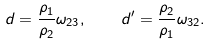<formula> <loc_0><loc_0><loc_500><loc_500>d = \frac { \rho _ { 1 } } { \rho _ { 2 } } \omega _ { 2 3 } , \quad d ^ { \prime } = \frac { \rho _ { 2 } } { \rho _ { 1 } } \omega _ { 3 2 } .</formula> 